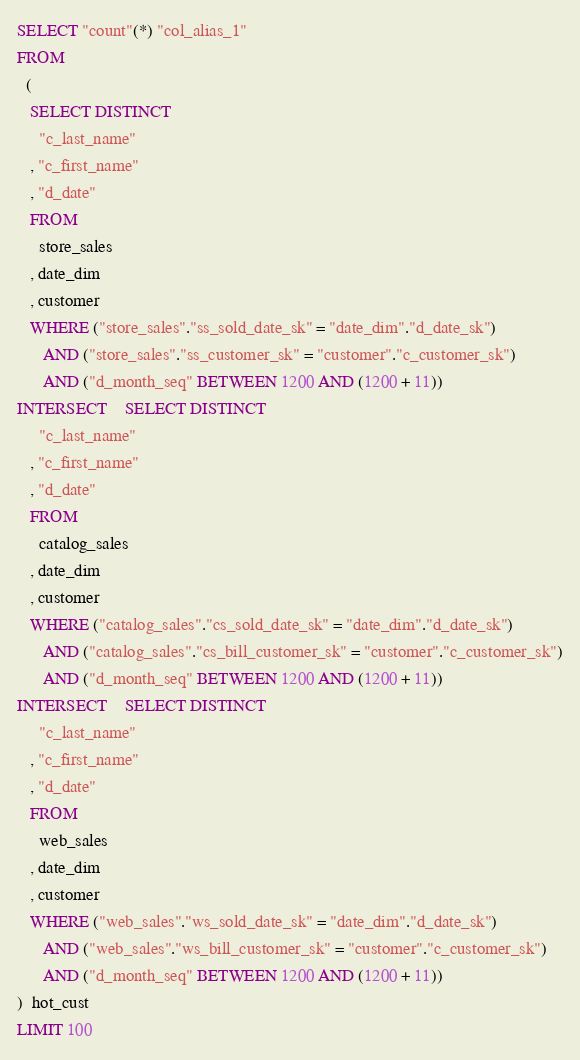Convert code to text. <code><loc_0><loc_0><loc_500><loc_500><_SQL_>SELECT "count"(*) "col_alias_1"
FROM
  (
   SELECT DISTINCT
     "c_last_name"
   , "c_first_name"
   , "d_date"
   FROM
     store_sales
   , date_dim
   , customer
   WHERE ("store_sales"."ss_sold_date_sk" = "date_dim"."d_date_sk")
      AND ("store_sales"."ss_customer_sk" = "customer"."c_customer_sk")
      AND ("d_month_seq" BETWEEN 1200 AND (1200 + 11))
INTERSECT    SELECT DISTINCT
     "c_last_name"
   , "c_first_name"
   , "d_date"
   FROM
     catalog_sales
   , date_dim
   , customer
   WHERE ("catalog_sales"."cs_sold_date_sk" = "date_dim"."d_date_sk")
      AND ("catalog_sales"."cs_bill_customer_sk" = "customer"."c_customer_sk")
      AND ("d_month_seq" BETWEEN 1200 AND (1200 + 11))
INTERSECT    SELECT DISTINCT
     "c_last_name"
   , "c_first_name"
   , "d_date"
   FROM
     web_sales
   , date_dim
   , customer
   WHERE ("web_sales"."ws_sold_date_sk" = "date_dim"."d_date_sk")
      AND ("web_sales"."ws_bill_customer_sk" = "customer"."c_customer_sk")
      AND ("d_month_seq" BETWEEN 1200 AND (1200 + 11))
)  hot_cust
LIMIT 100
</code> 